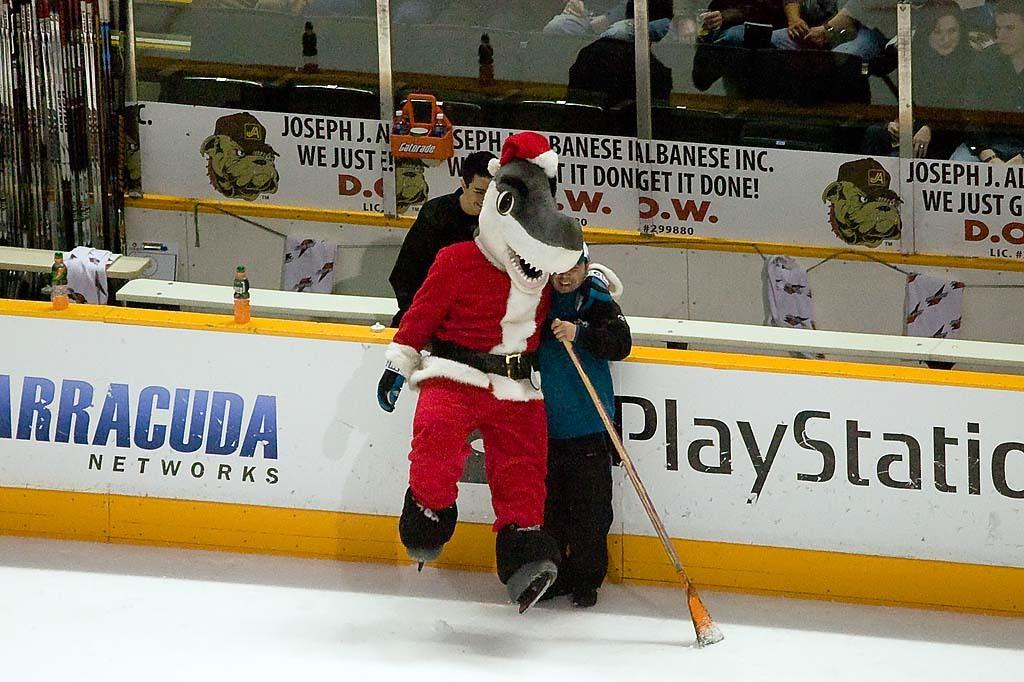<image>
Describe the image concisely. Santa Claus wearing a shark mask on a hockey field near a Playstation ad. 